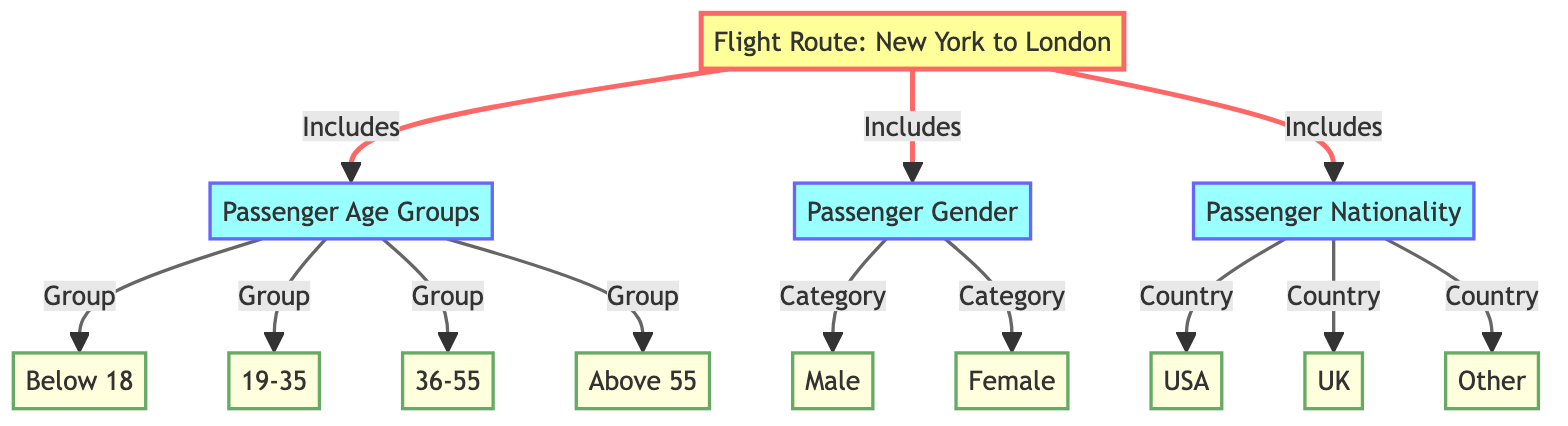What is the flight route represented in the diagram? The diagram specifies "Flight Route: New York to London" as the main node connected to various categories. Therefore, the flight route depicted in the diagram is directly mentioned in the title node.
Answer: New York to London How many passenger age groups are listed in the diagram? The diagram contains four distinct age groups represented as subcategories under the "Passenger Age Groups" node. These groups are Below 18, 19-35, 36-55, and Above 55. Therefore, by counting these groups, we find there are four age groups.
Answer: 4 Which gender category is included in the diagram? The diagram presents "Passenger Gender" as a category with two subcategories: Male and Female. The gender category is expressed specifically within the diagram, making it evident that these two genders are included.
Answer: Male, Female What nationality is mentioned as the category with the highest representation in the diagram? The diagram includes three subcategories under "Passenger Nationality": USA, UK, and Other. By analyzing these categories, the answer is determined by simply looking at the explicit mention of the subcategories, without a specified indication of representation.
Answer: N/A How are passenger age groups and passenger gender connected in the diagram? In the diagram, "Passenger Age Groups" and "Passenger Gender" are both direct inclusions from the "Flight Route: New York to London." This shows a direct relationship where both categories fall under the same flight route, but they do not interact or connect directly with each other inherently in this structure.
Answer: Both are under the Flight Route How many total subcategories are outlined under Passenger Nationality? The diagram reveals three subcategories linked under "Passenger Nationality." These subcategories include USA, UK, and Other. Thus, counting these entries provides the total number of subcategories.
Answer: 3 What distinguishes the arrow style for some nodes in this diagram? The diagram has a distinct link style for specified nodes, particularly certain edges that have been set to a different stroke width and color, indicative of importance or focus, in this case initiating from the main flight route towards specific age groups and gender categories.
Answer: Edge style differences What type of diagram is being used to convey passenger demographics? This diagram is classified as a "Textbook Diagram," primarily organized into hierarchical nodes representing different categories and subcategories of passenger demographics based on a specific flight route.
Answer: Textbook Diagram What is the classification of the node representing "Passenger Age Groups"? The node "Passenger Age Groups" is classified as a category; this is highlighted visually through its shading and the manner it connects to subcategories indicating respective age groups underneath it in the diagram's structure.
Answer: Category 